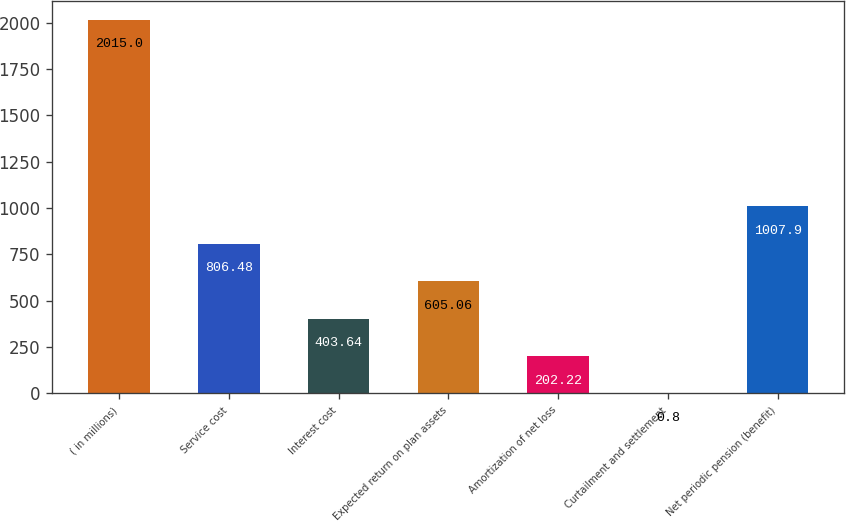Convert chart to OTSL. <chart><loc_0><loc_0><loc_500><loc_500><bar_chart><fcel>( in millions)<fcel>Service cost<fcel>Interest cost<fcel>Expected return on plan assets<fcel>Amortization of net loss<fcel>Curtailment and settlement<fcel>Net periodic pension (benefit)<nl><fcel>2015<fcel>806.48<fcel>403.64<fcel>605.06<fcel>202.22<fcel>0.8<fcel>1007.9<nl></chart> 